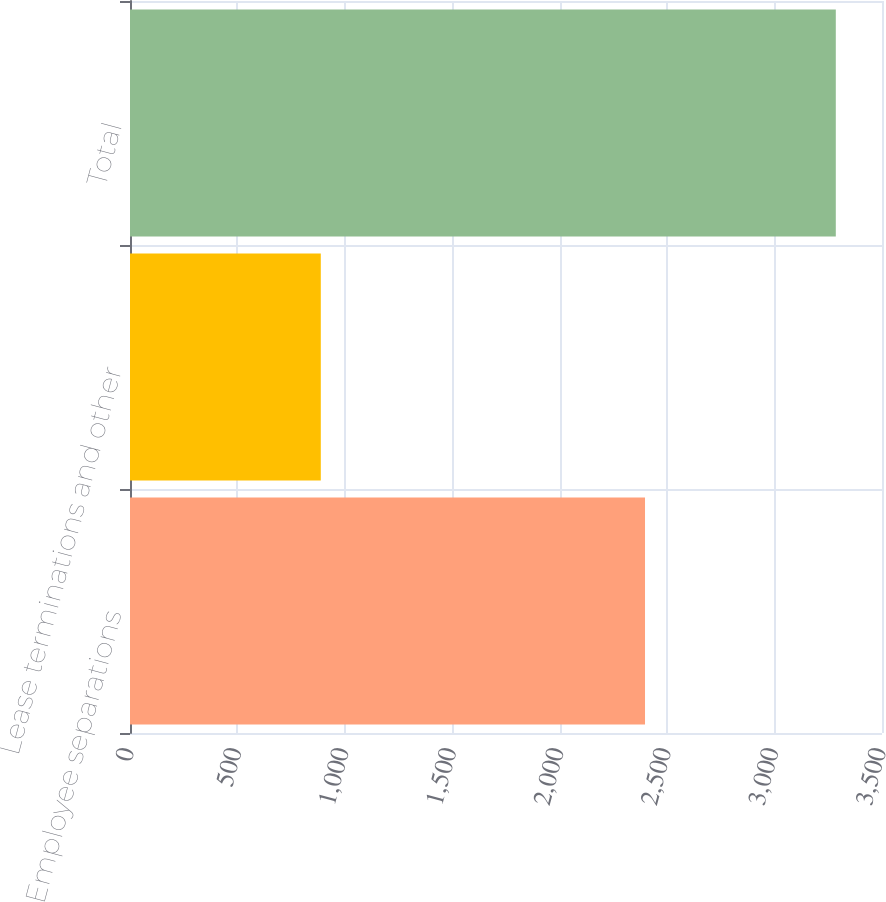Convert chart to OTSL. <chart><loc_0><loc_0><loc_500><loc_500><bar_chart><fcel>Employee separations<fcel>Lease terminations and other<fcel>Total<nl><fcel>2397<fcel>888<fcel>3285<nl></chart> 